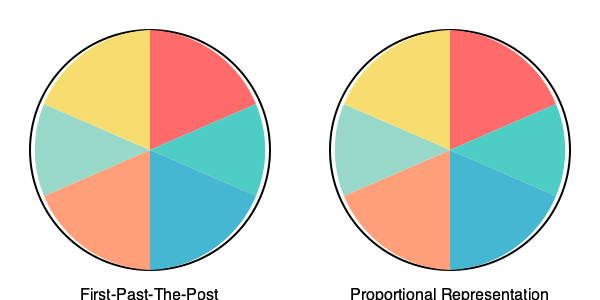Based on the pie charts representing seat allocation in two different electoral systems, which system appears to provide a more proportional representation of voter preferences, and how might this impact the strategy of an opposition party seeking to strengthen its platform? To answer this question, let's analyze the pie charts step by step:

1. First-Past-The-Post (FPTP) System:
   - Shows a disproportionate distribution of seats
   - The largest slice (red) occupies about 40% of the pie
   - Other slices vary significantly in size

2. Proportional Representation (PR) System:
   - Shows a more balanced distribution of seats
   - All slices are relatively similar in size
   - No single party dominates the chart

3. Comparison:
   - PR system appears to provide more proportional representation
   - In FPTP, smaller parties may be underrepresented
   - PR allows for better representation of diverse voter preferences

4. Impact on opposition strategy:
   - In FPTP, opposition might focus on key swing constituencies
   - In PR, opposition can appeal to a broader base
   - PR encourages coalition-building and compromise

5. Platform strengthening:
   - Under PR, opposition can focus on niche issues to attract specific voter groups
   - In FPTP, opposition might need to adopt broader policies to appeal to larger voter blocks
   - PR allows for more nuanced policy positions

6. Long-term implications:
   - PR system may lead to more stable long-term representation for opposition
   - FPTP might require more dramatic shifts in platform to gain significant representation

Given these observations, the Proportional Representation system appears to provide a more balanced representation of voter preferences. This would allow an opposition party to focus on developing a platform that accurately reflects their core values and the interests of their target voter base, rather than having to dramatically alter their positions to appeal to a broader audience as might be necessary in a First-Past-The-Post system.
Answer: Proportional Representation; allows opposition to focus on core values and build coalitions. 